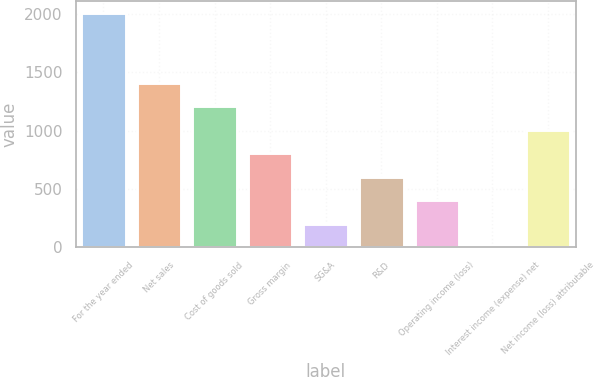<chart> <loc_0><loc_0><loc_500><loc_500><bar_chart><fcel>For the year ended<fcel>Net sales<fcel>Cost of goods sold<fcel>Gross margin<fcel>SG&A<fcel>R&D<fcel>Operating income (loss)<fcel>Interest income (expense) net<fcel>Net income (loss) attributable<nl><fcel>2012<fcel>1409<fcel>1208<fcel>806<fcel>203<fcel>605<fcel>404<fcel>2<fcel>1007<nl></chart> 